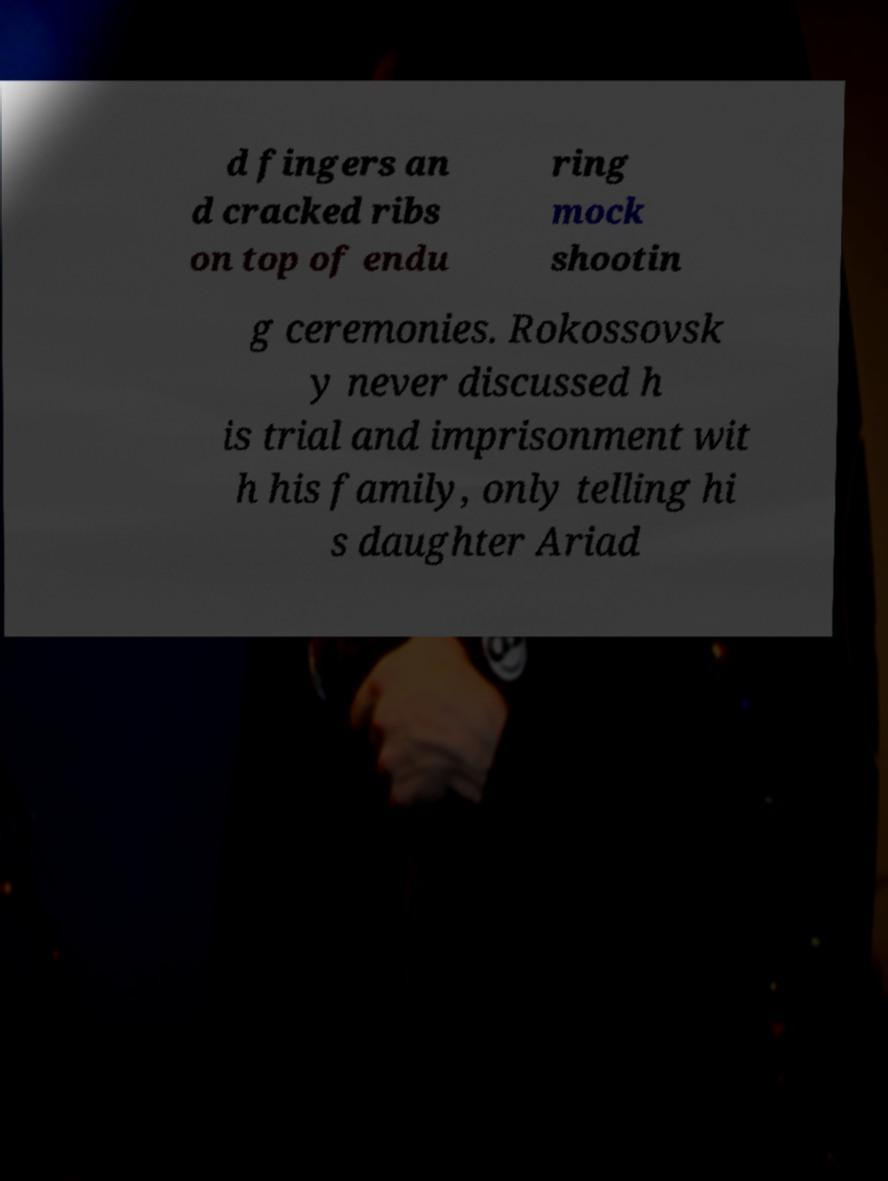I need the written content from this picture converted into text. Can you do that? d fingers an d cracked ribs on top of endu ring mock shootin g ceremonies. Rokossovsk y never discussed h is trial and imprisonment wit h his family, only telling hi s daughter Ariad 